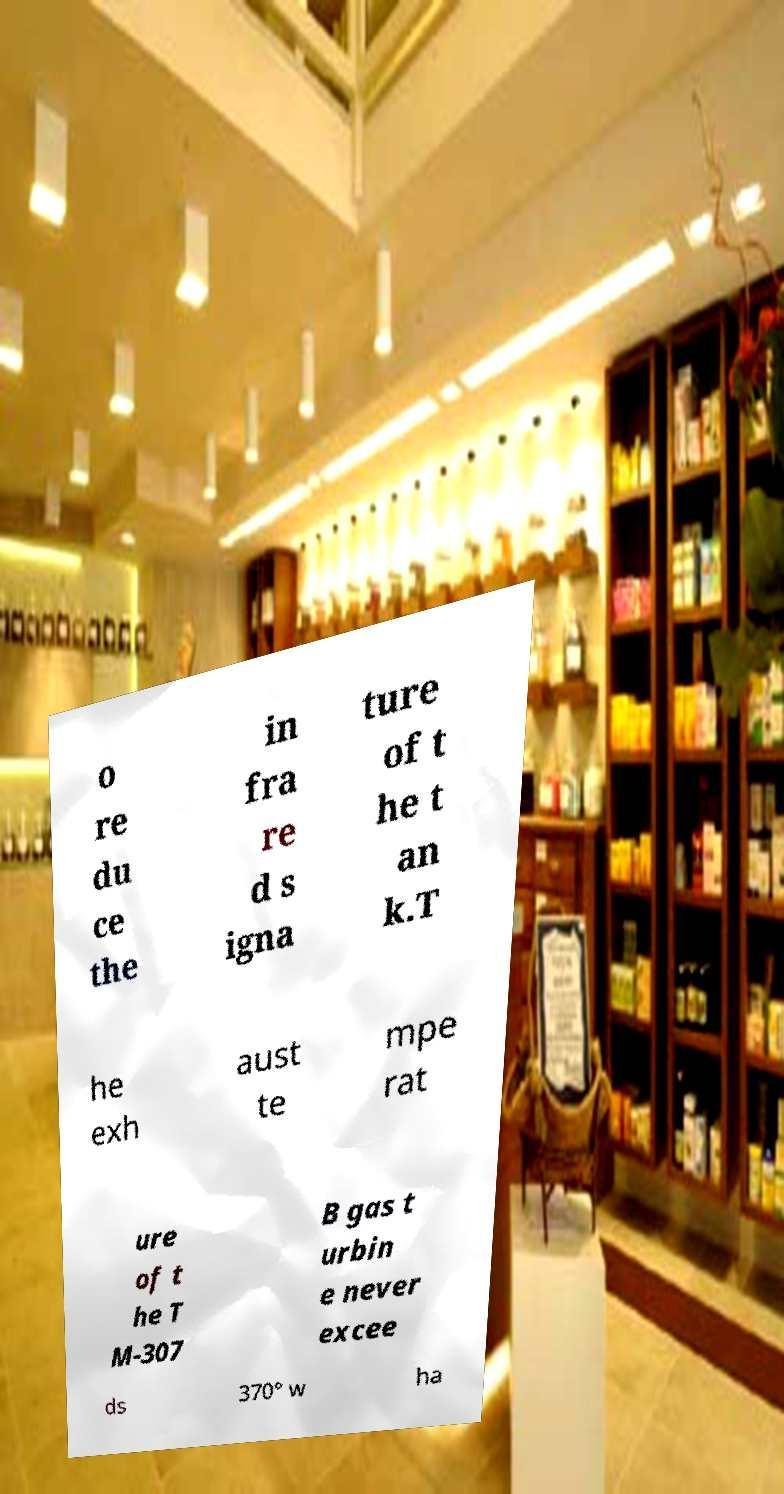Please identify and transcribe the text found in this image. o re du ce the in fra re d s igna ture of t he t an k.T he exh aust te mpe rat ure of t he T M-307 B gas t urbin e never excee ds 370° w ha 